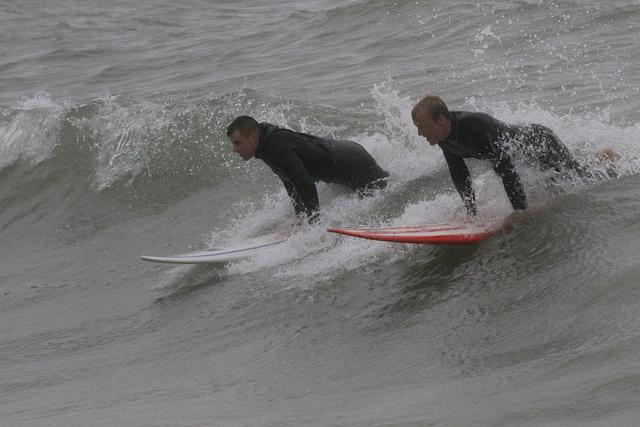How many people are surfing?
Write a very short answer. 2. What are the men in the photo doing?
Quick response, please. Surfing. Is this the ocean?
Give a very brief answer. Yes. 